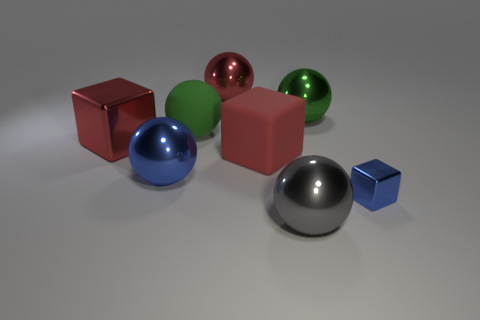Subtract all green balls. How many were subtracted if there are1green balls left? 1 Subtract all big blocks. How many blocks are left? 1 Add 1 large cyan shiny spheres. How many objects exist? 9 Subtract all blue balls. How many balls are left? 4 Subtract all spheres. How many objects are left? 3 Subtract 1 blocks. How many blocks are left? 2 Add 7 gray matte objects. How many gray matte objects exist? 7 Subtract 0 gray blocks. How many objects are left? 8 Subtract all green blocks. Subtract all cyan cylinders. How many blocks are left? 3 Subtract all green spheres. How many red cubes are left? 2 